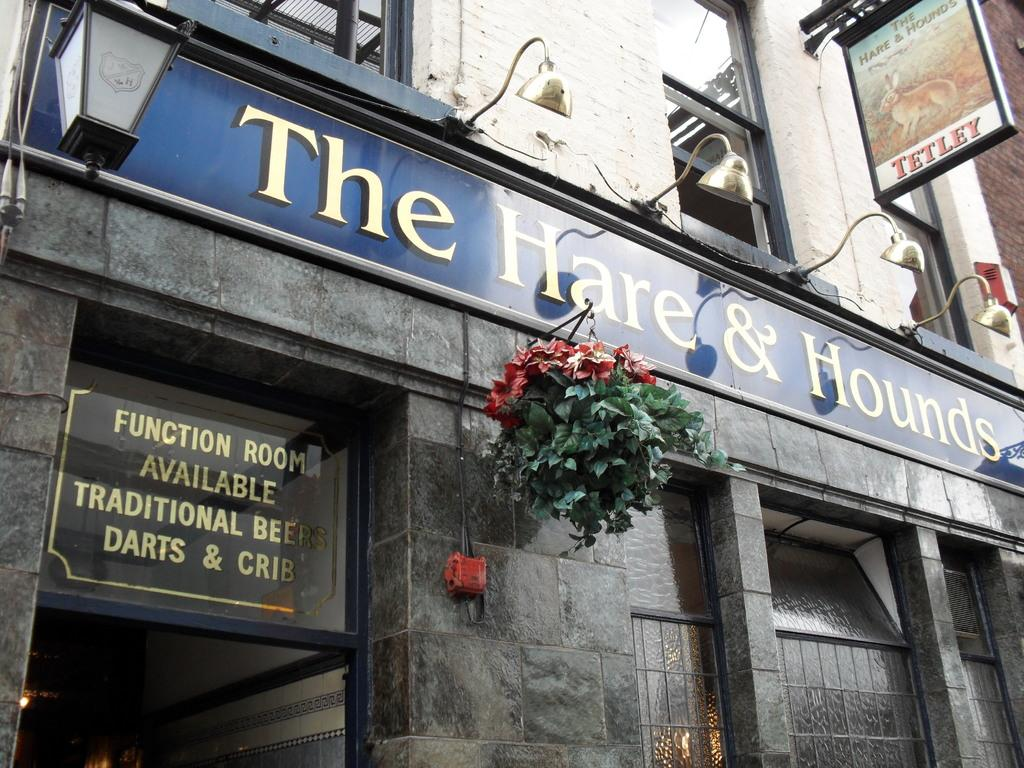<image>
Share a concise interpretation of the image provided. Some flowers hang below The Hare & Hounds restaurant. 